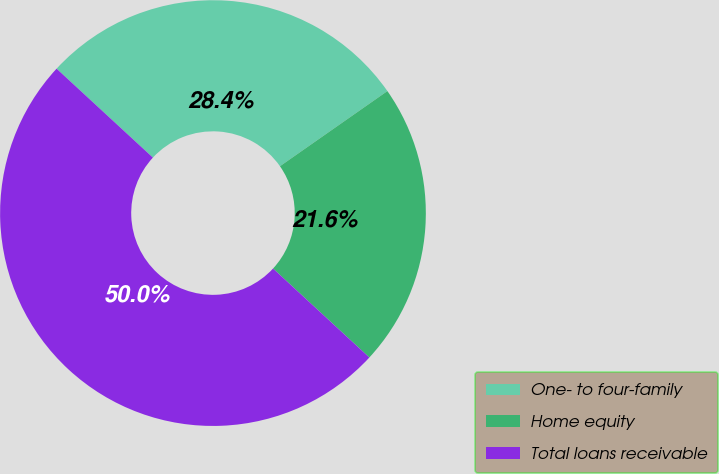Convert chart to OTSL. <chart><loc_0><loc_0><loc_500><loc_500><pie_chart><fcel>One- to four-family<fcel>Home equity<fcel>Total loans receivable<nl><fcel>28.42%<fcel>21.58%<fcel>50.0%<nl></chart> 